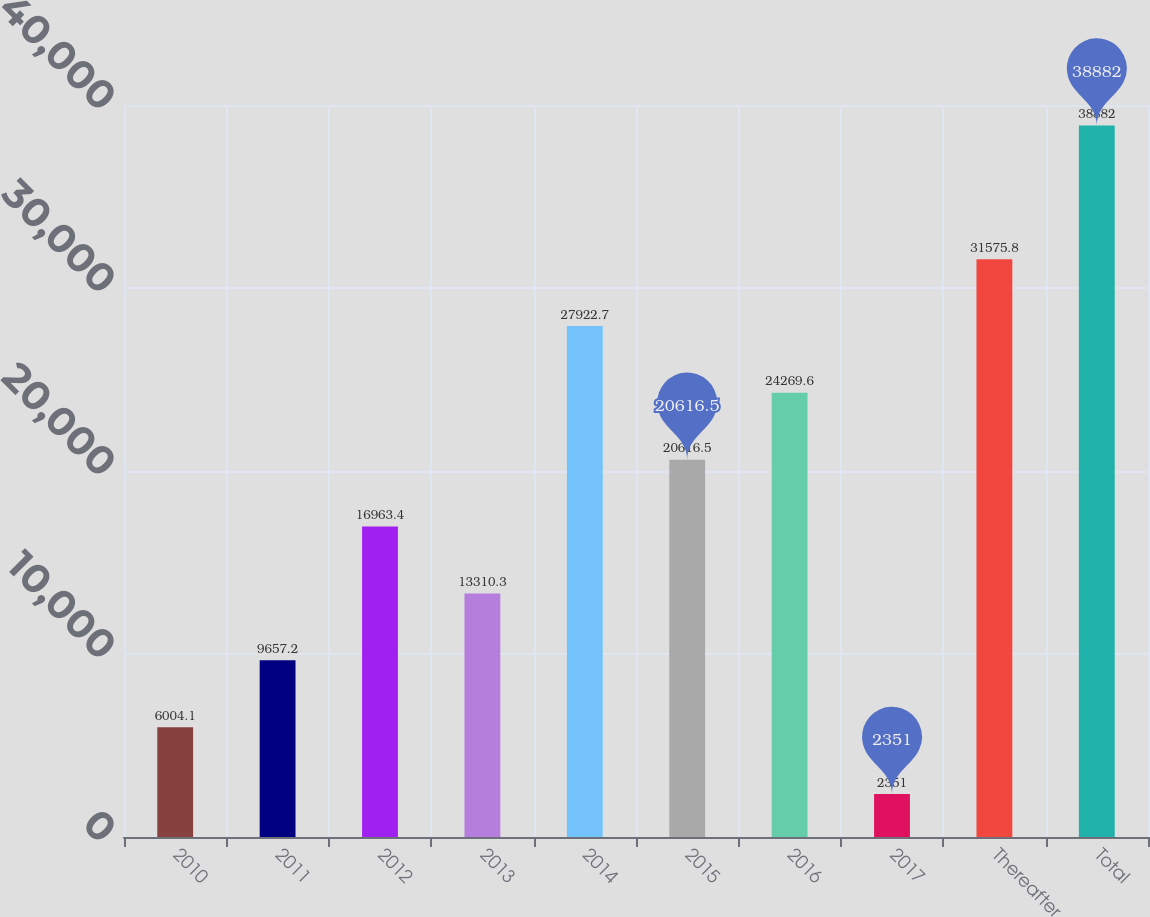<chart> <loc_0><loc_0><loc_500><loc_500><bar_chart><fcel>2010<fcel>2011<fcel>2012<fcel>2013<fcel>2014<fcel>2015<fcel>2016<fcel>2017<fcel>Thereafter<fcel>Total<nl><fcel>6004.1<fcel>9657.2<fcel>16963.4<fcel>13310.3<fcel>27922.7<fcel>20616.5<fcel>24269.6<fcel>2351<fcel>31575.8<fcel>38882<nl></chart> 